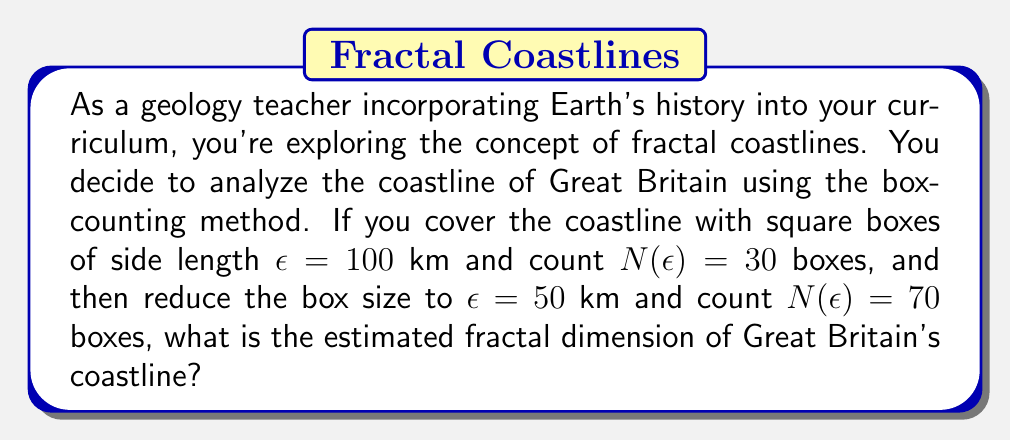Can you solve this math problem? To solve this problem, we'll use the box-counting method to estimate the fractal dimension of the coastline. The fractal dimension $D$ is given by the formula:

$$D = \lim_{\epsilon \to 0} \frac{\log N(\epsilon)}{\log(1/\epsilon)}$$

Where $N(\epsilon)$ is the number of boxes of side length $\epsilon$ needed to cover the coastline.

For practical purposes, we can estimate the fractal dimension using two different scales:

$$D \approx \frac{\log N(\epsilon_2) - \log N(\epsilon_1)}{\log(1/\epsilon_2) - \log(1/\epsilon_1)}$$

Let's plug in our values:
$\epsilon_1 = 100$ km, $N(\epsilon_1) = 30$
$\epsilon_2 = 50$ km, $N(\epsilon_2) = 70$

Now, let's calculate step by step:

1) $\log N(\epsilon_2) - \log N(\epsilon_1) = \log 70 - \log 30$

2) $\log(1/\epsilon_2) - \log(1/\epsilon_1) = \log(1/50) - \log(1/100) = \log 2$

3) Substituting into our formula:

   $$D \approx \frac{\log 70 - \log 30}{\log 2}$$

4) Calculate the numerator:
   $\log 70 \approx 4.2485$
   $\log 30 \approx 3.4012$
   $4.2485 - 3.4012 \approx 0.8473$

5) $\log 2 \approx 0.6931$

6) Final calculation:
   $$D \approx \frac{0.8473}{0.6931} \approx 1.2224$$

This result is consistent with typical fractal dimensions for coastlines, which usually fall between 1 (a smooth line) and 2 (a plane-filling curve).
Answer: The estimated fractal dimension of Great Britain's coastline is approximately 1.22. 